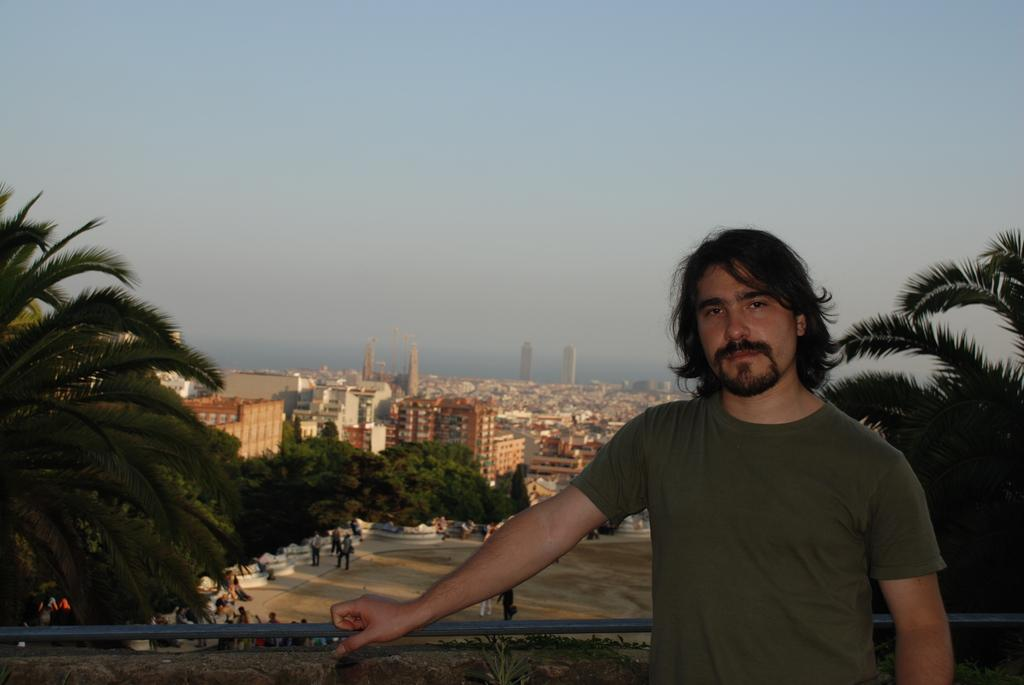What is the main subject of the image? There is a person standing in the image. What can be seen in the background of the image? There are trees, buildings, and the sky visible in the background of the image. What type of carriage is being pulled by the horses in the image? There are no horses or carriages present in the image. What type of apparel is the person wearing in the image? The provided facts do not mention the person's apparel, so we cannot answer this question definitively. 